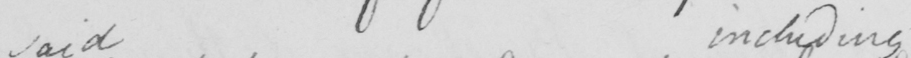Please provide the text content of this handwritten line. said including 